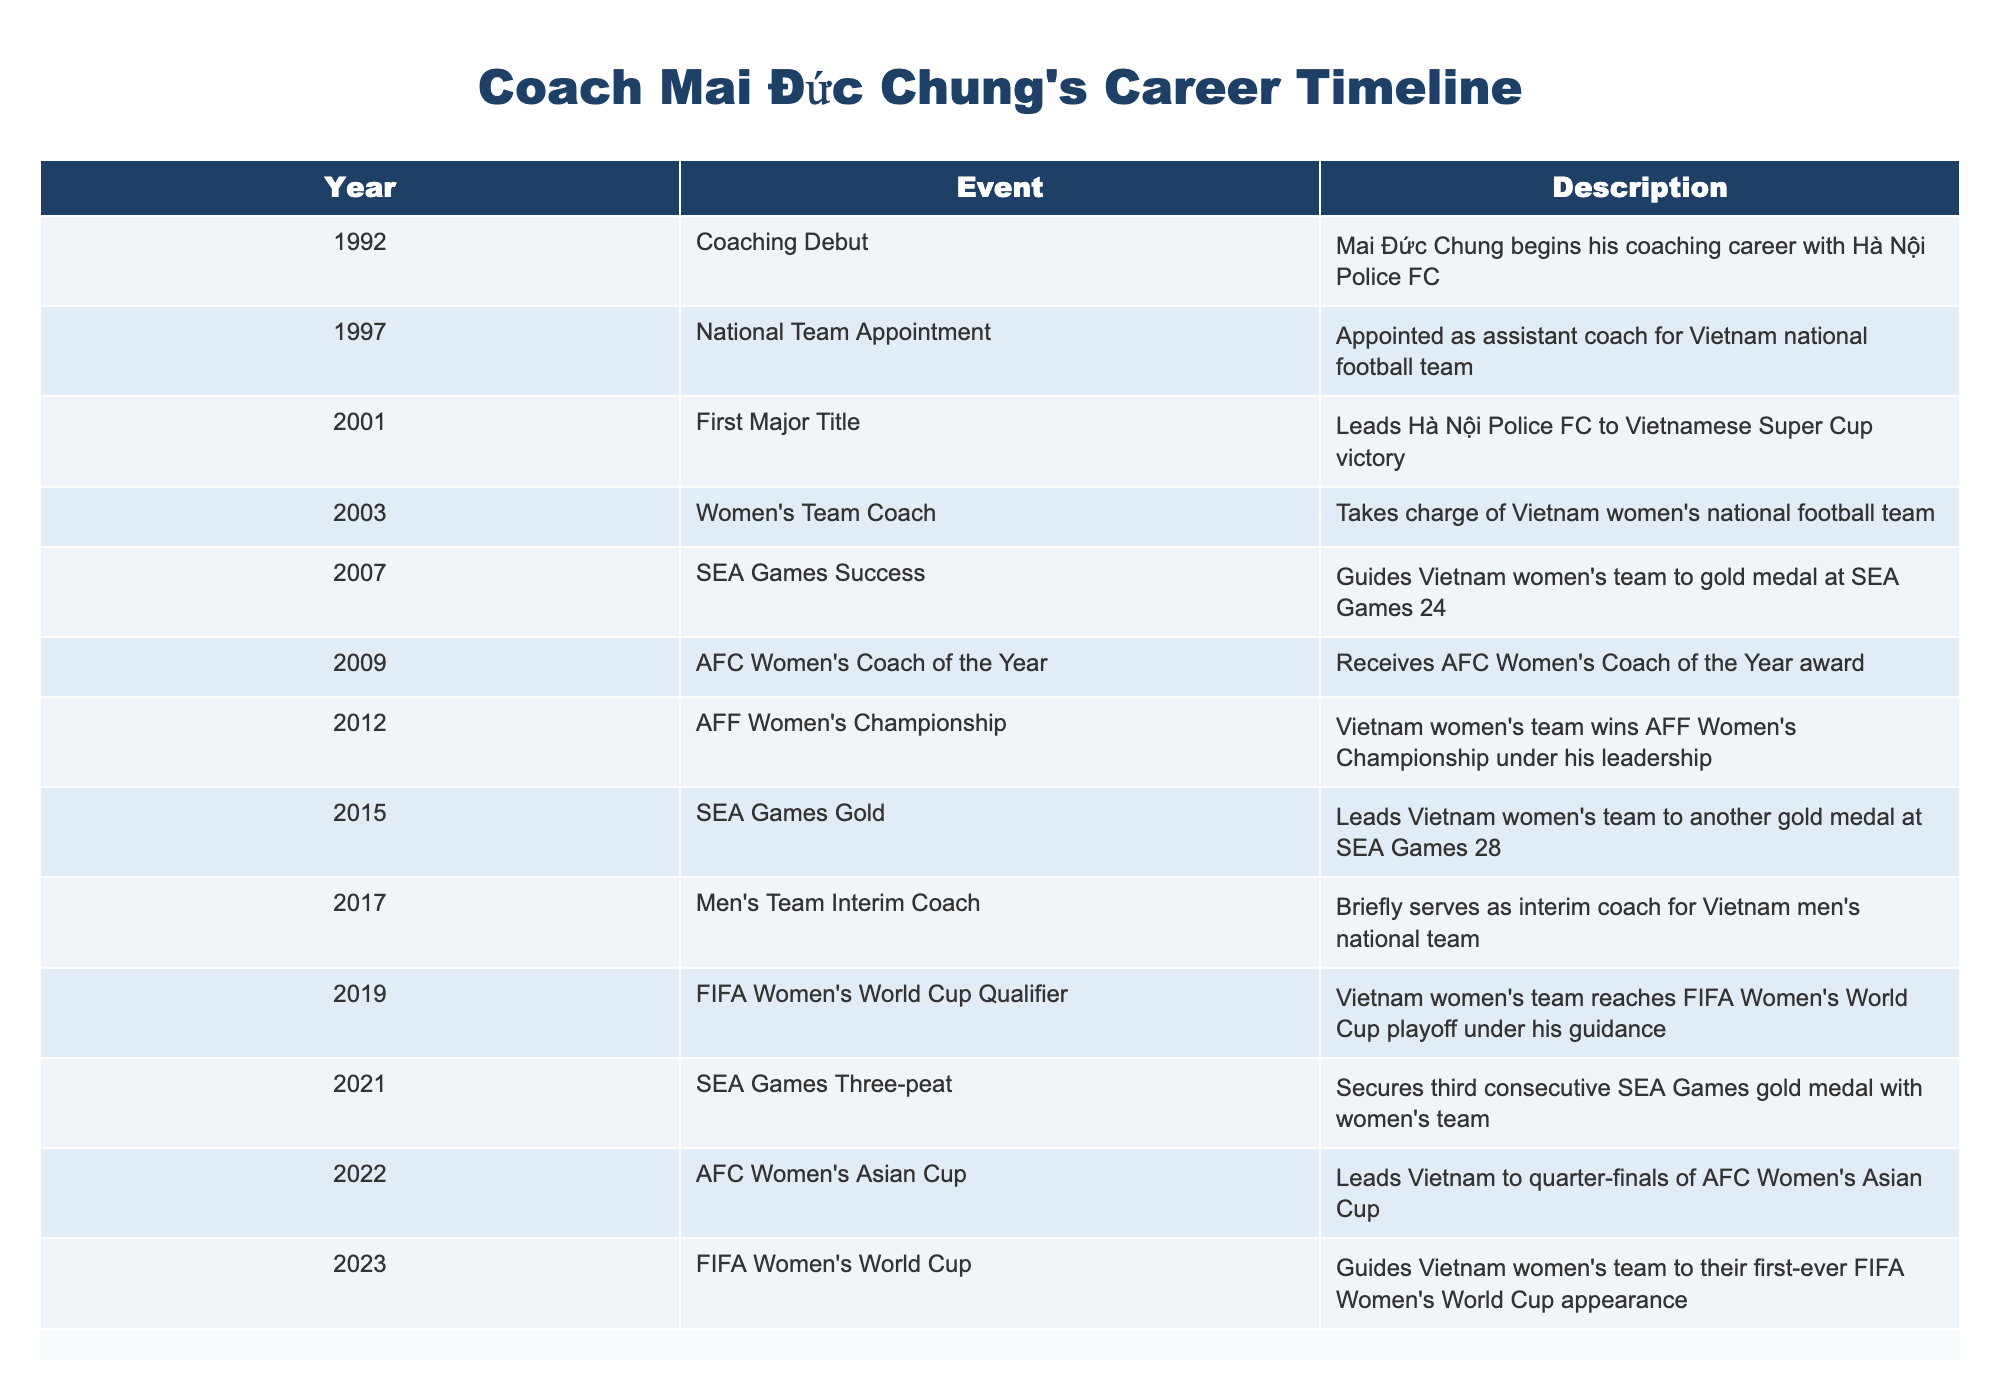What year did Coach Mai Đức Chung start his coaching career? According to the table, Coach Mai Đức Chung began his coaching career in 1992, as indicated in the first row under the 'Year' and 'Event' columns.
Answer: 1992 How many major titles did he win with Hà Nội Police FC? Based on the table, he won one major title with Hà Nội Police FC which is noted in the event for the year 2001 under 'First Major Title.'
Answer: One Did Coach Mai Đức Chung lead Vietnam's women's team to an AFF Women's Championship victory? The table shows that he led the women's team to win the AFF Women's Championship in 2012, confirming that he did indeed achieve this.
Answer: Yes In which year did the Vietnam women's team first qualify for the FIFA Women's World Cup? The table registers that the Vietnam women's team reached the FIFA Women's World Cup playoff in 2019, which is their first step towards qualification for the tournament.
Answer: 2019 What is the total number of SEA Games gold medals won under his leadership? By examining the rows related to SEA Games, we see gold medals were won in 2007, 2015, and 2021, totaling three gold medals throughout his career. Therefore, these three titles count as the total number of SEA Games gold medals won under his guidance.
Answer: Three Was Coach Mai Đức Chung appointed as the assistant coach for the Vietnam national football team before he became the coach for the women's team? Referring to the events listed, he was appointed as the assistant coach in 1997 and took charge of the Vietnam women's team in 2003, confirming that he served as the assistant coach before leading the women's team.
Answer: Yes How many years were there between the first time he led Vietnam women's team to a gold medal at the SEA Games and their latest gold medal under him? The first SEA Games gold was achieved in 2007 and the latest was in 2021, making it a difference of 14 years between those two events.
Answer: 14 years What notable award did Coach Mai Đức Chung receive in 2009? The table indicates that in 2009, he received the AFC Women's Coach of the Year award, marking a significant achievement in his coaching career.
Answer: AFC Women's Coach of the Year Which event marks the first time Vietnam's women's team participated in the FIFA Women's World Cup? The event listed for 2023 mentions that he guided the Vietnam women's team to their first-ever FIFA Women's World Cup appearance, which is a major milestone.
Answer: 2023 